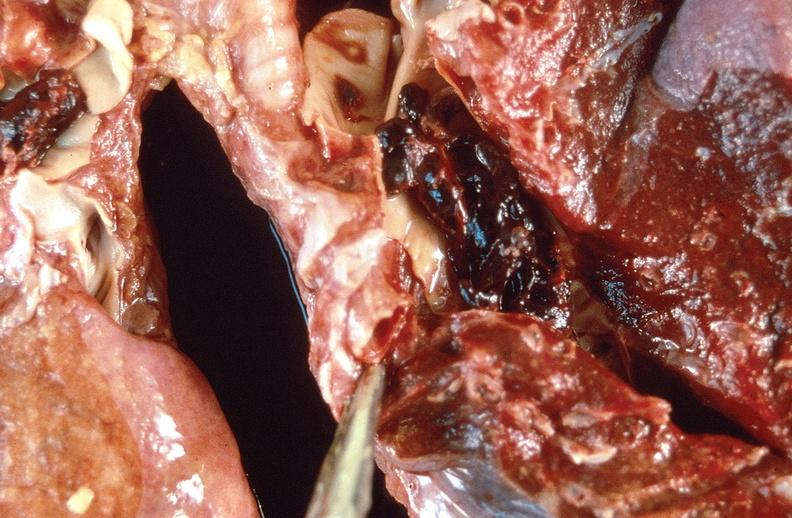what does this image show?
Answer the question using a single word or phrase. Pulmonary thromboemboli 